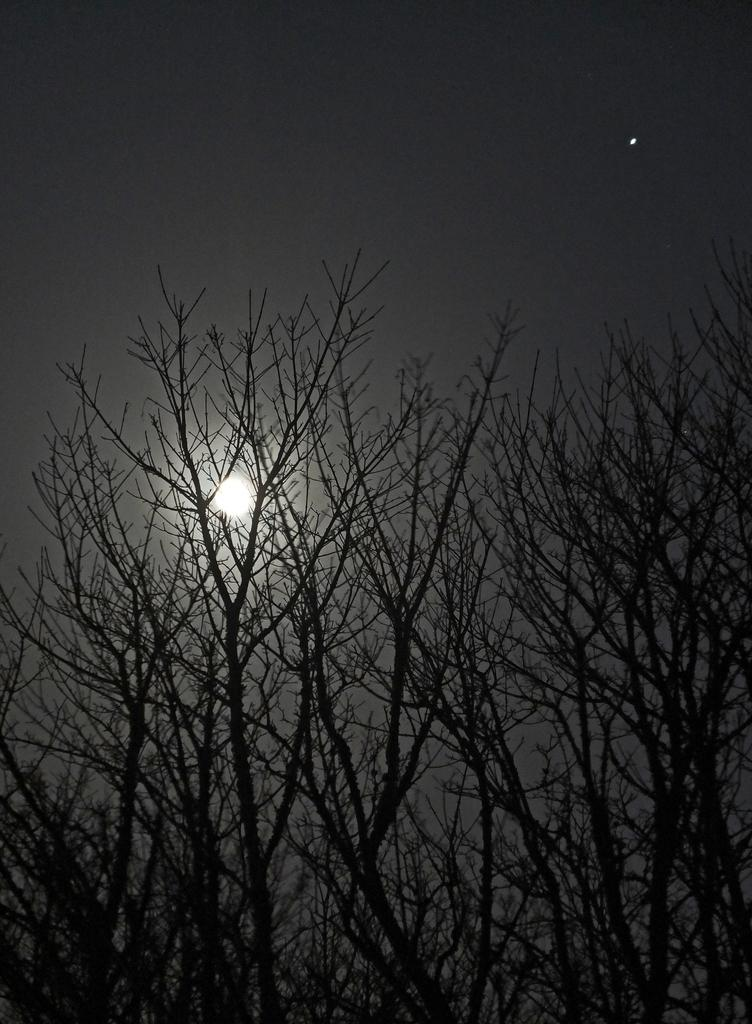What can be seen at the top of the image? The sky is visible in the image. What type of vegetation is present in the image? There are trees in the image. What type of grass can be seen growing in the stomach of the person in the image? There is no person present in the image, and therefore no stomach or grass can be observed. 